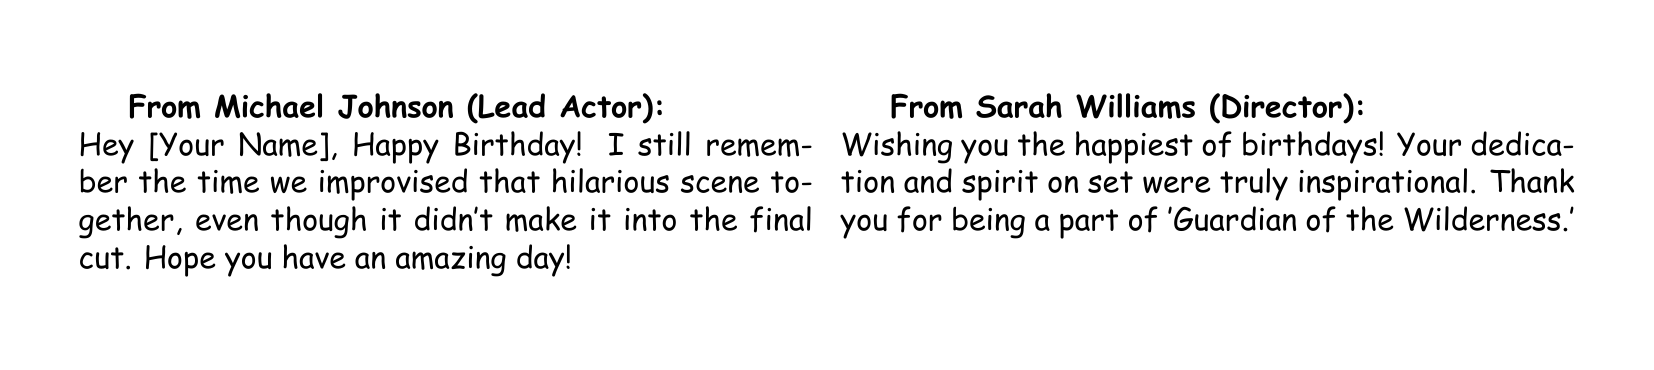What is the title of the greeting card? The title of the greeting card is prominently displayed at the top, stating the occasion celebrated.
Answer: Happy Birthday! Who is the lead actor who sent a message? The lead actor's name is included in the message section of the card.
Answer: Michael Johnson How many illustrations of movie props are included on the card? The card is decorated with illustrated movie props, although the exact number is represented visually.
Answer: Four What is the profession of Sarah Williams? Sarah Williams is identified by her role in the card messages, relating to the production of the film.
Answer: Director Which character element did Emily Hernandez mention? The personalized message highlights a specific aspect of the film's making that relates to her role.
Answer: Wardrobe changes What sentiment does Jessica Nguyen express in her message? The message reflects Jessica's feelings about her experiences with the recipient during the filming.
Answer: Kindness What color is the top section of the card? The color of specific sections is mentioned, particularly the topmost part of the card.
Answer: Red What profession is David Lee associated with? David Lee's role is indicated within the messages from cast and crew members featured in the card.
Answer: Cinematographer 